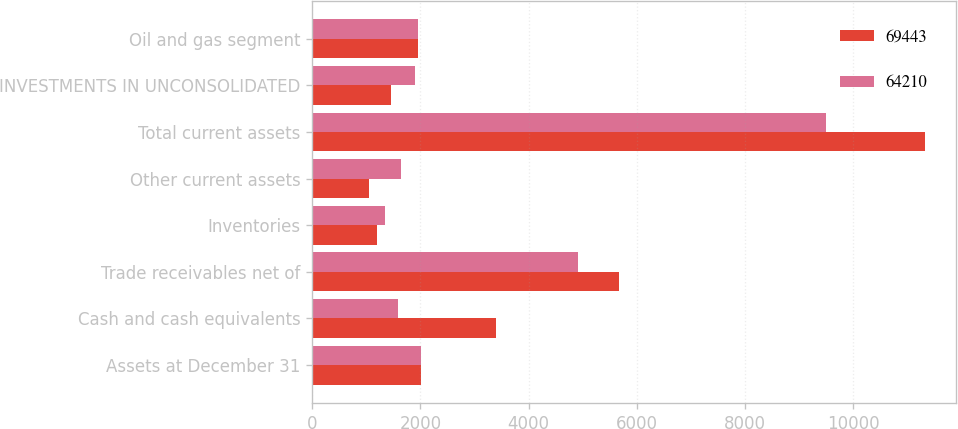Convert chart to OTSL. <chart><loc_0><loc_0><loc_500><loc_500><stacked_bar_chart><ecel><fcel>Assets at December 31<fcel>Cash and cash equivalents<fcel>Trade receivables net of<fcel>Inventories<fcel>Other current assets<fcel>Total current assets<fcel>INVESTMENTS IN UNCONSOLIDATED<fcel>Oil and gas segment<nl><fcel>69443<fcel>2013<fcel>3393<fcel>5674<fcel>1200<fcel>1056<fcel>11323<fcel>1459<fcel>1953<nl><fcel>64210<fcel>2012<fcel>1592<fcel>4916<fcel>1344<fcel>1640<fcel>9492<fcel>1894<fcel>1953<nl></chart> 